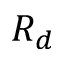<formula> <loc_0><loc_0><loc_500><loc_500>R _ { d }</formula> 